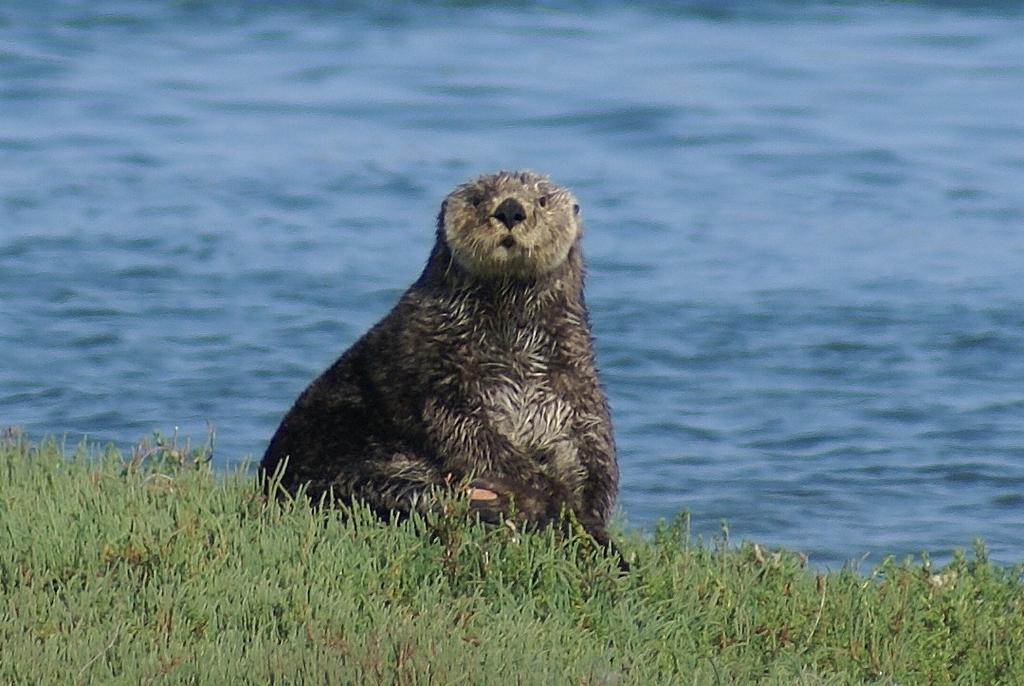Could you give a brief overview of what you see in this image? In this picture we can see grass at the bottom, there is the sea otter in the middle, in the background we can see water. 